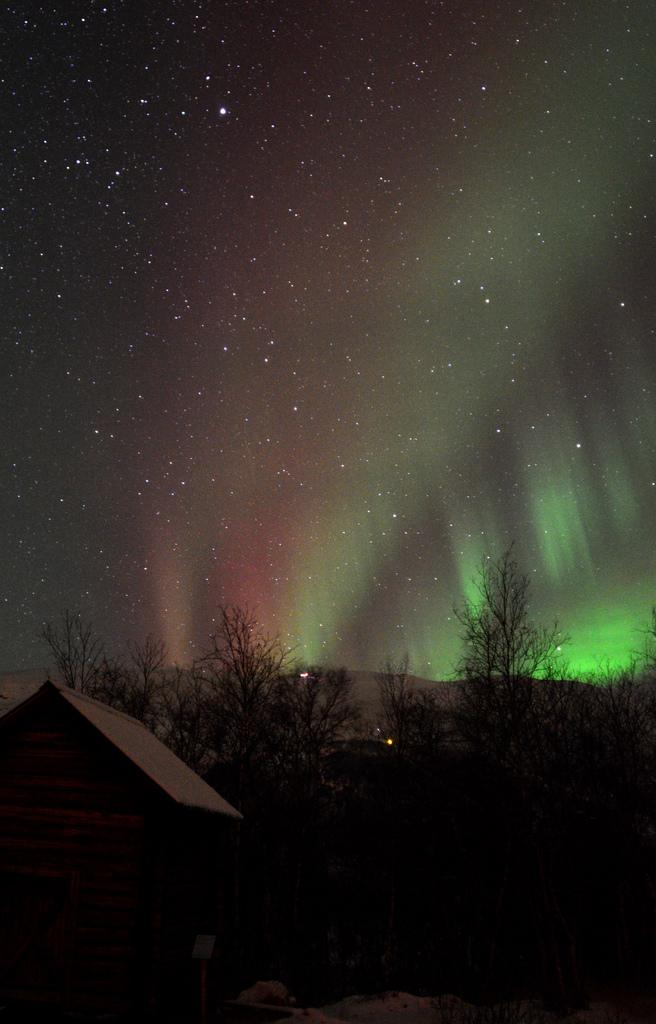What types of living organisms can be seen in the image? Plants are visible in the image. What type of structure can be seen in the image? There is a house in the image. What can be seen in the background of the image? Light rays are visible in the background of the image. What is visible at the top of the image? The sky is visible at the top of the image. Where are the scissors located in the image? There are no scissors present in the image. What type of crown can be seen on the plants in the image? There are no crowns present on the plants in the image. 